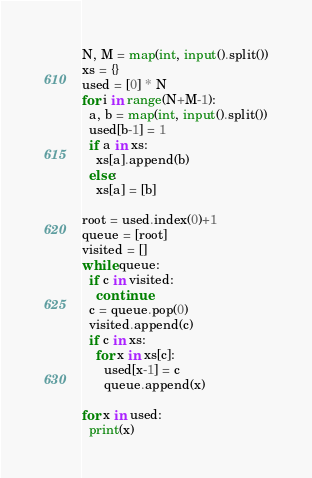<code> <loc_0><loc_0><loc_500><loc_500><_Python_>N, M = map(int, input().split())
xs = {}
used = [0] * N
for i in range(N+M-1):
  a, b = map(int, input().split())
  used[b-1] = 1
  if a in xs:
  	xs[a].append(b)
  else:
    xs[a] = [b]
 
root = used.index(0)+1
queue = [root]
visited = []
while queue:
  if c in visited:
    continue
  c = queue.pop(0)
  visited.append(c)
  if c in xs:
    for x in xs[c]:
      used[x-1] = c
      queue.append(x)

for x in used:
  print(x)</code> 